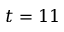<formula> <loc_0><loc_0><loc_500><loc_500>t = 1 1</formula> 